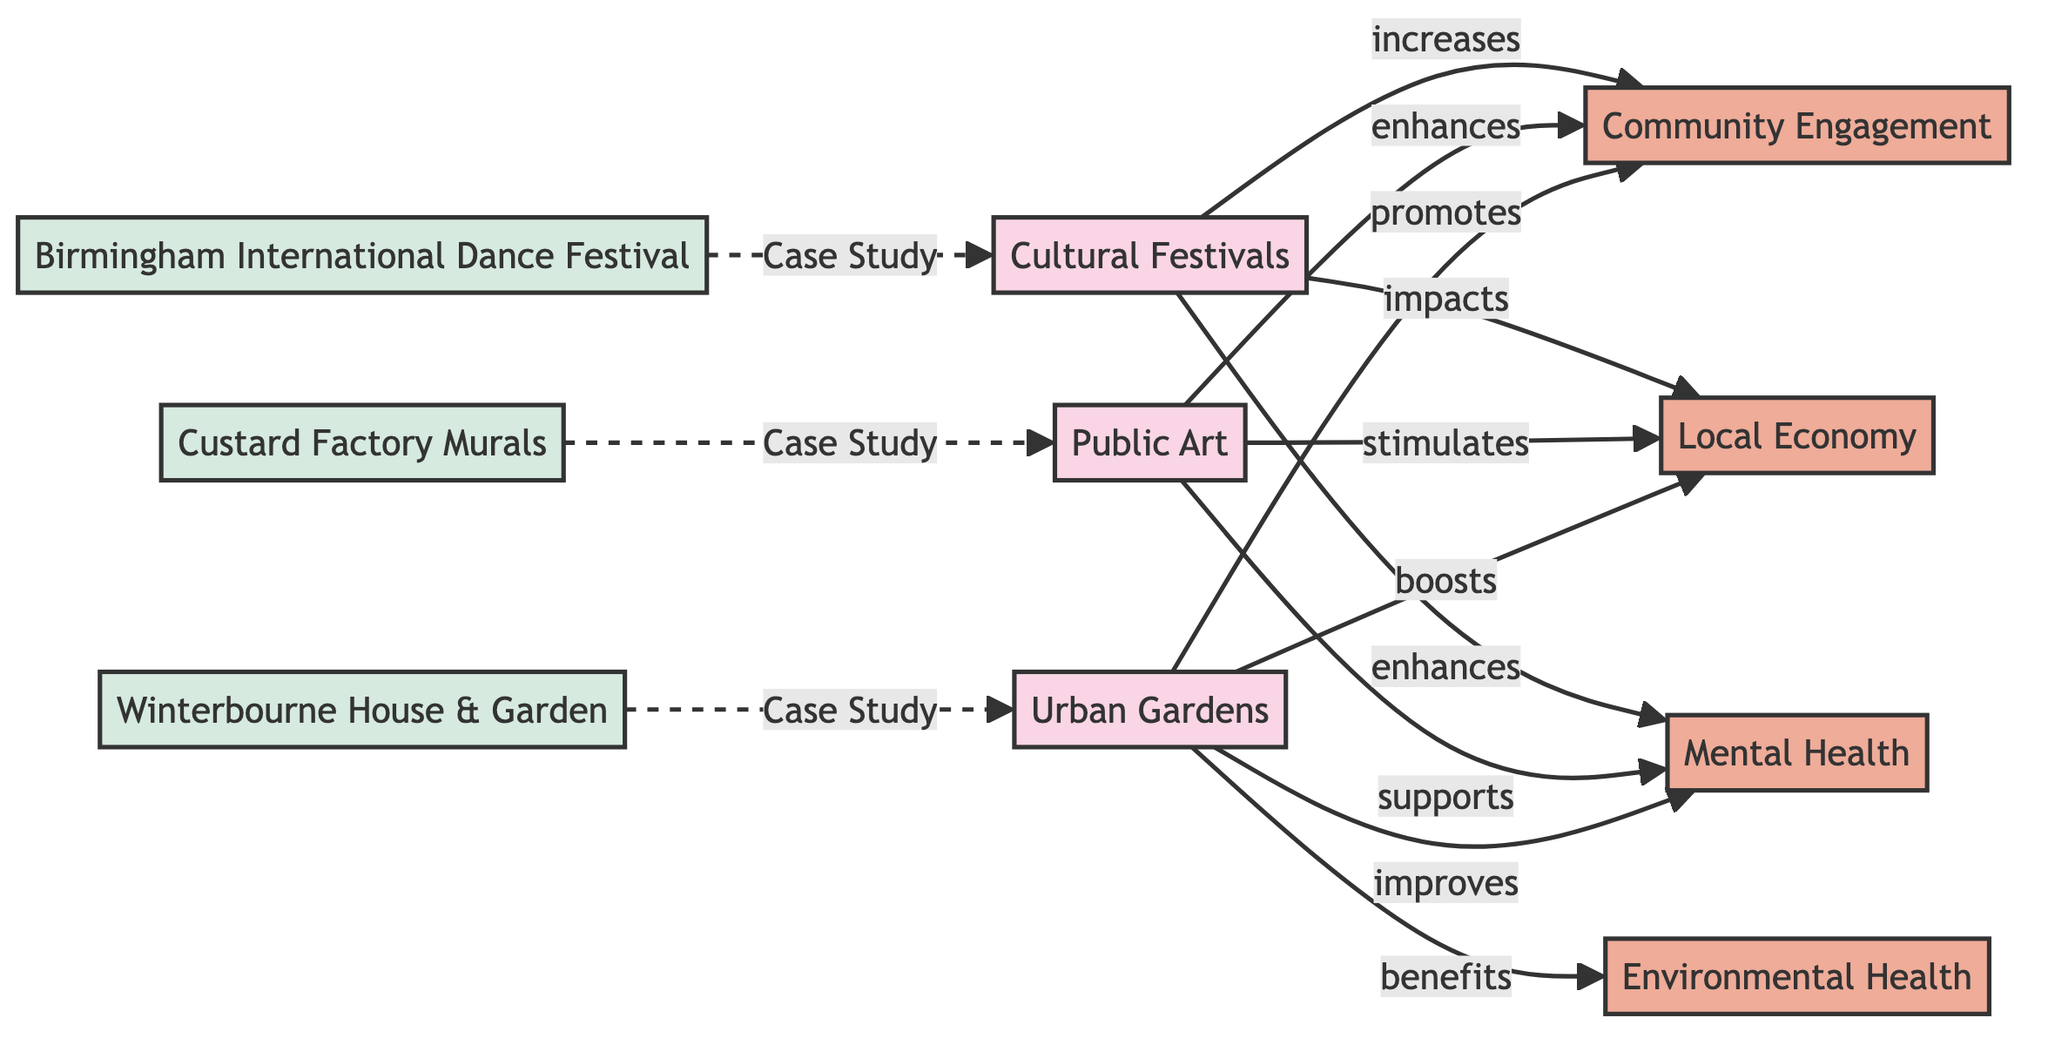What are the three local community projects listed in the diagram? The diagram outlines three primary projects: Urban Gardens, Public Art, and Cultural Festivals. These are presented at the top of the diagram as the main nodes.
Answer: Urban Gardens, Public Art, Cultural Festivals How many impacts are identified in the diagram? The diagram illustrates four distinct impacts resulting from the listed community projects: Community Engagement, Local Economy, Mental Health, and Environmental Health. This can be counted by identifying the impact nodes connected to the projects.
Answer: Four What type of impact do Urban Gardens have on Mental Health? The relationship shown in the diagram indicates that Urban Gardens "improves" Mental Health, based on the labeled connection between these two nodes.
Answer: Improves Which project is associated with Winterbourne House & Garden? The diagram denotes that Winterbourne House & Garden serves as a case study specifically under the Urban Gardens project, visually linking it with a dashed line.
Answer: Urban Gardens How do Cultural Festivals affect the Local Economy? According to the diagram, Cultural Festivals "impacts" the Local Economy, indicating a positive influence that can be directly traced through the labeled connection.
Answer: Impacts What type of connection links Public Art to Community Engagement? The relationship between Public Art and Community Engagement in the diagram is characterized as "enhances," illustrating how Public Art contributes to increased engagement within the community.
Answer: Enhances Which project benefits Environmental Health? The diagram specifies that Urban Gardens have a direct benefit to Environmental Health, as identified by the labeled connection from Urban Gardens to Environmental Health.
Answer: Urban Gardens How many examples of case studies are provided in the diagram? The diagram lists three specific case study examples linked to the projects: Winterbourne House & Garden, Custard Factory Murals, and Birmingham International Dance Festival. By counting these dashed connections, one can confirm the total number.
Answer: Three What is the effect of Cultural Festivals on Mental Health? The diagram indicates that Cultural Festivals "enhances" Mental Health, showing a direct connection that describes this positive effect.
Answer: Enhances 